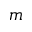<formula> <loc_0><loc_0><loc_500><loc_500>m</formula> 